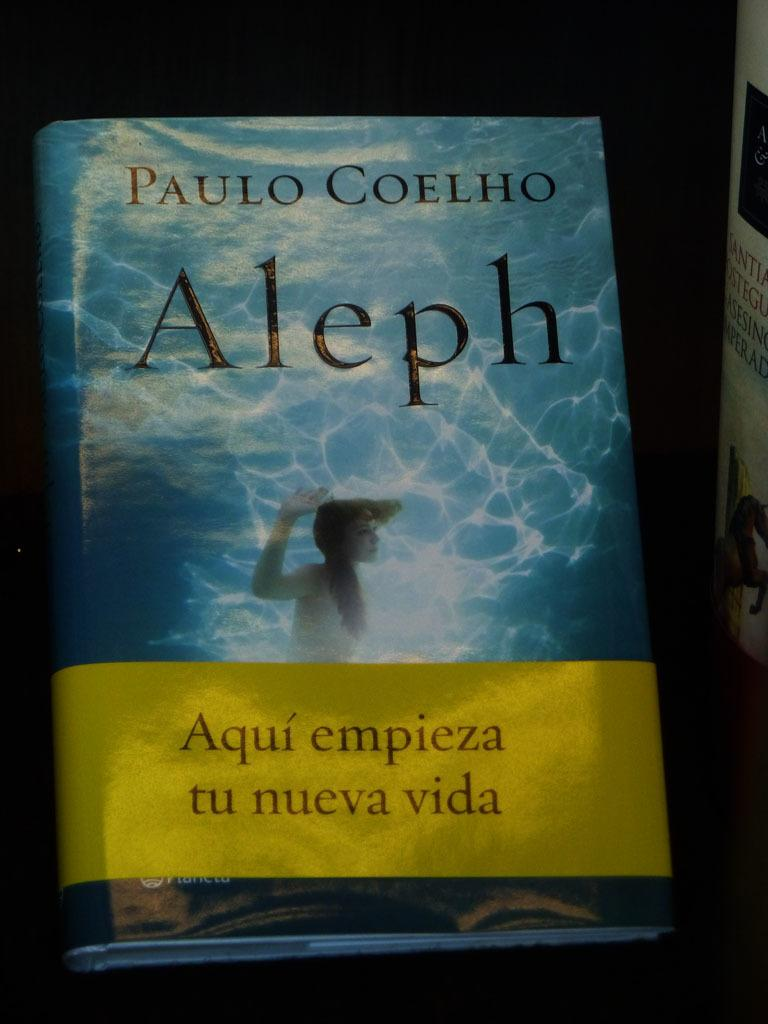<image>
Render a clear and concise summary of the photo. A copy of Paulo Coelho's Aleph novel on a dark surface. 